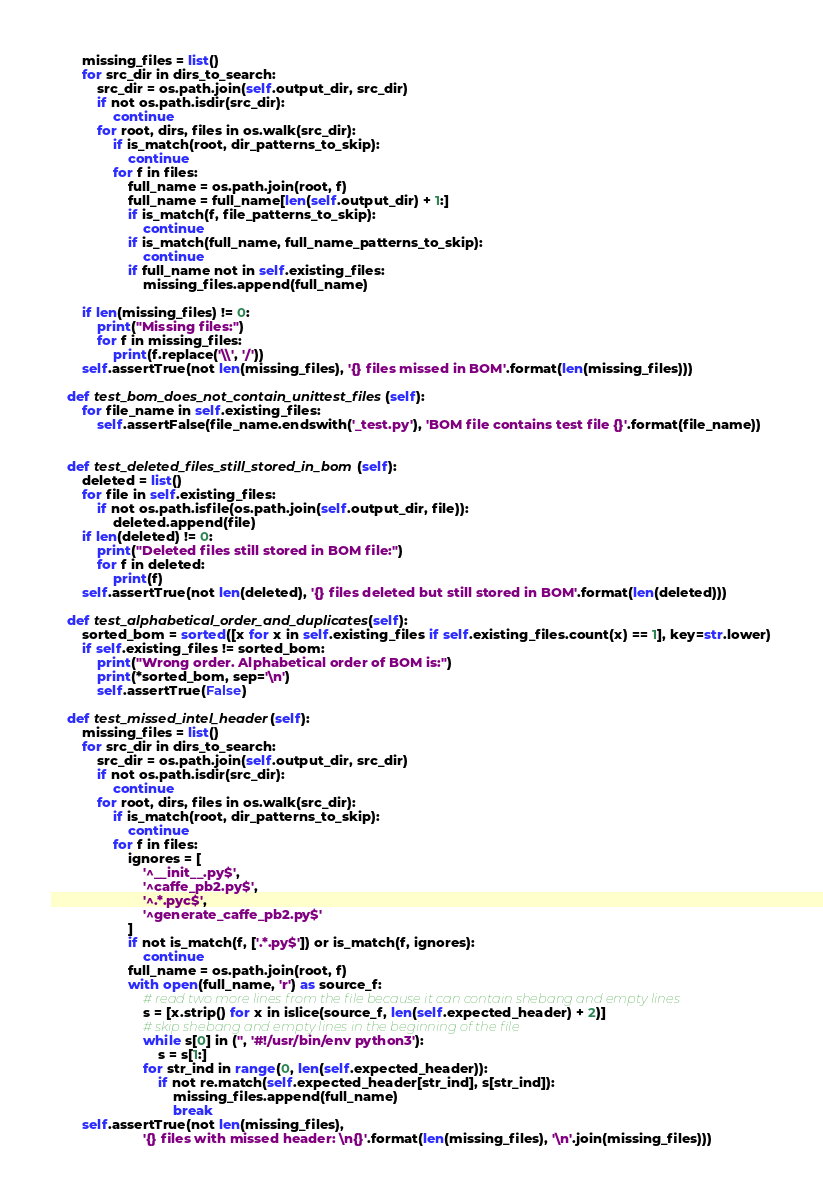Convert code to text. <code><loc_0><loc_0><loc_500><loc_500><_Python_>        missing_files = list()
        for src_dir in dirs_to_search:
            src_dir = os.path.join(self.output_dir, src_dir)
            if not os.path.isdir(src_dir):
                continue
            for root, dirs, files in os.walk(src_dir):
                if is_match(root, dir_patterns_to_skip):
                    continue
                for f in files:
                    full_name = os.path.join(root, f)
                    full_name = full_name[len(self.output_dir) + 1:]
                    if is_match(f, file_patterns_to_skip):
                        continue
                    if is_match(full_name, full_name_patterns_to_skip):
                        continue
                    if full_name not in self.existing_files:
                        missing_files.append(full_name)

        if len(missing_files) != 0:
            print("Missing files:")
            for f in missing_files:
                print(f.replace('\\', '/'))
        self.assertTrue(not len(missing_files), '{} files missed in BOM'.format(len(missing_files)))

    def test_bom_does_not_contain_unittest_files(self):
        for file_name in self.existing_files:
            self.assertFalse(file_name.endswith('_test.py'), 'BOM file contains test file {}'.format(file_name))
                

    def test_deleted_files_still_stored_in_bom(self):
        deleted = list()
        for file in self.existing_files:
            if not os.path.isfile(os.path.join(self.output_dir, file)):
                deleted.append(file)
        if len(deleted) != 0:
            print("Deleted files still stored in BOM file:")
            for f in deleted:
                print(f)
        self.assertTrue(not len(deleted), '{} files deleted but still stored in BOM'.format(len(deleted)))

    def test_alphabetical_order_and_duplicates(self):
        sorted_bom = sorted([x for x in self.existing_files if self.existing_files.count(x) == 1], key=str.lower)
        if self.existing_files != sorted_bom:
            print("Wrong order. Alphabetical order of BOM is:")
            print(*sorted_bom, sep='\n')
            self.assertTrue(False)

    def test_missed_intel_header(self):
        missing_files = list()
        for src_dir in dirs_to_search:
            src_dir = os.path.join(self.output_dir, src_dir)
            if not os.path.isdir(src_dir):
                continue
            for root, dirs, files in os.walk(src_dir):
                if is_match(root, dir_patterns_to_skip):
                    continue
                for f in files:
                    ignores = [
                        '^__init__.py$',
                        '^caffe_pb2.py$',
                        '^.*.pyc$',
                        '^generate_caffe_pb2.py$'
                    ]
                    if not is_match(f, ['.*.py$']) or is_match(f, ignores):
                        continue
                    full_name = os.path.join(root, f)
                    with open(full_name, 'r') as source_f:
                        # read two more lines from the file because it can contain shebang and empty lines
                        s = [x.strip() for x in islice(source_f, len(self.expected_header) + 2)]
                        # skip shebang and empty lines in the beginning of the file
                        while s[0] in ('', '#!/usr/bin/env python3'):
                            s = s[1:]
                        for str_ind in range(0, len(self.expected_header)):
                            if not re.match(self.expected_header[str_ind], s[str_ind]):
                                missing_files.append(full_name)
                                break
        self.assertTrue(not len(missing_files),
                        '{} files with missed header: \n{}'.format(len(missing_files), '\n'.join(missing_files)))
</code> 